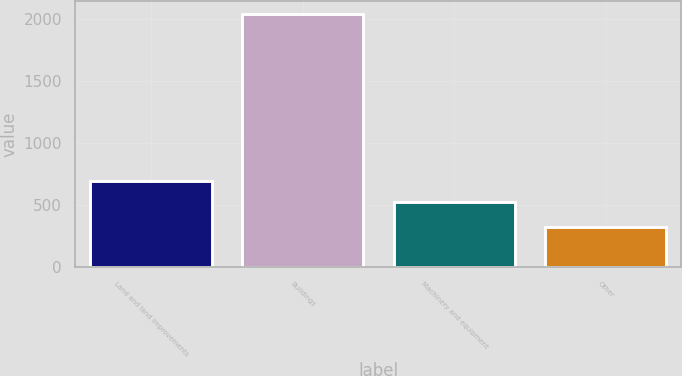Convert chart. <chart><loc_0><loc_0><loc_500><loc_500><bar_chart><fcel>Land and land improvements<fcel>Buildings<fcel>Machinery and equipment<fcel>Other<nl><fcel>697<fcel>2040<fcel>525<fcel>320<nl></chart> 